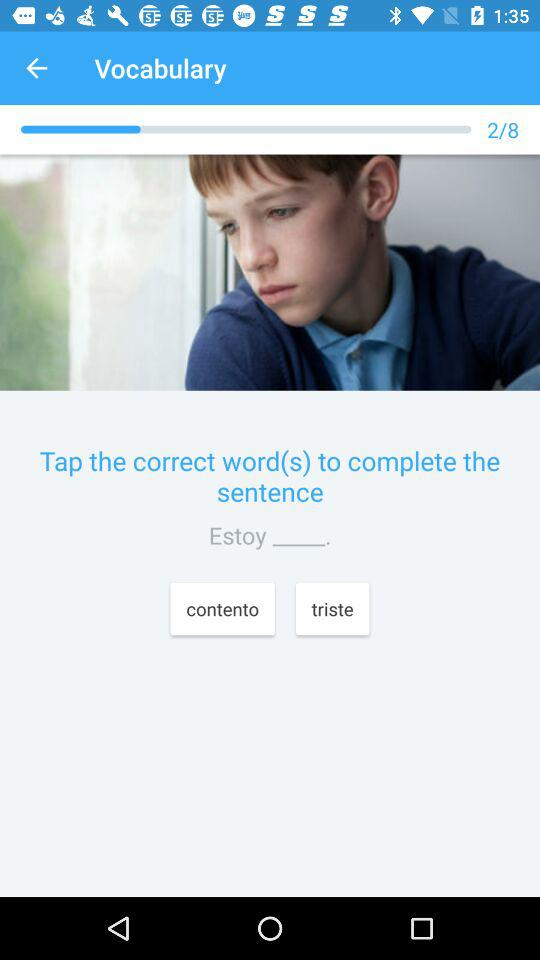How many total questions? The total questions are 8. 